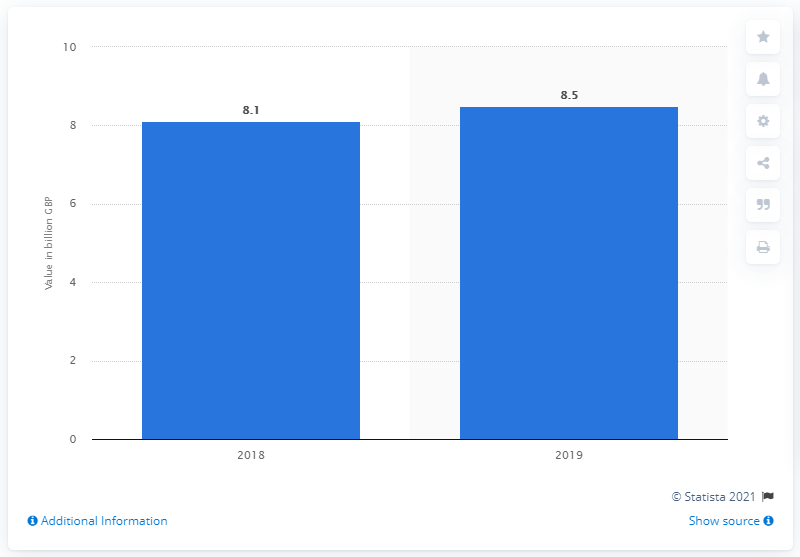Identify some key points in this picture. The foodservice delivery market in the UK was valued at approximately 8.5 billion dollars in 2019. In 2018, the value of the foodservice delivery market was 8.1 billion dollars. 